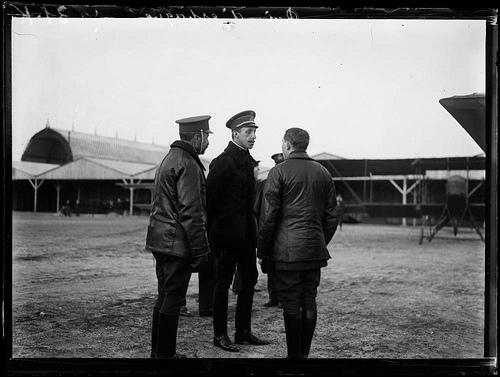How many people in this photo are wearing hats?
Give a very brief answer. 2. Is there a plane in the photo?
Short answer required. Yes. What color is the man's hat?
Write a very short answer. Black. Are the people in the picture happy?
Quick response, please. No. Is this near water?
Short answer required. No. Where is he?
Write a very short answer. Airfield. Do the people appear to be young adults or middle-aged adults?
Concise answer only. Middle aged. How many people are in this photo?
Answer briefly. 3. Does the man have cargo pants?
Concise answer only. No. Is the weather hot?
Quick response, please. No. What is the man walking along side of?
Keep it brief. Plane. How many people are there?
Write a very short answer. 3. Are they standing on rocks?
Quick response, please. No. How many people are shown?
Concise answer only. 3. How many men are there?
Keep it brief. 3. 